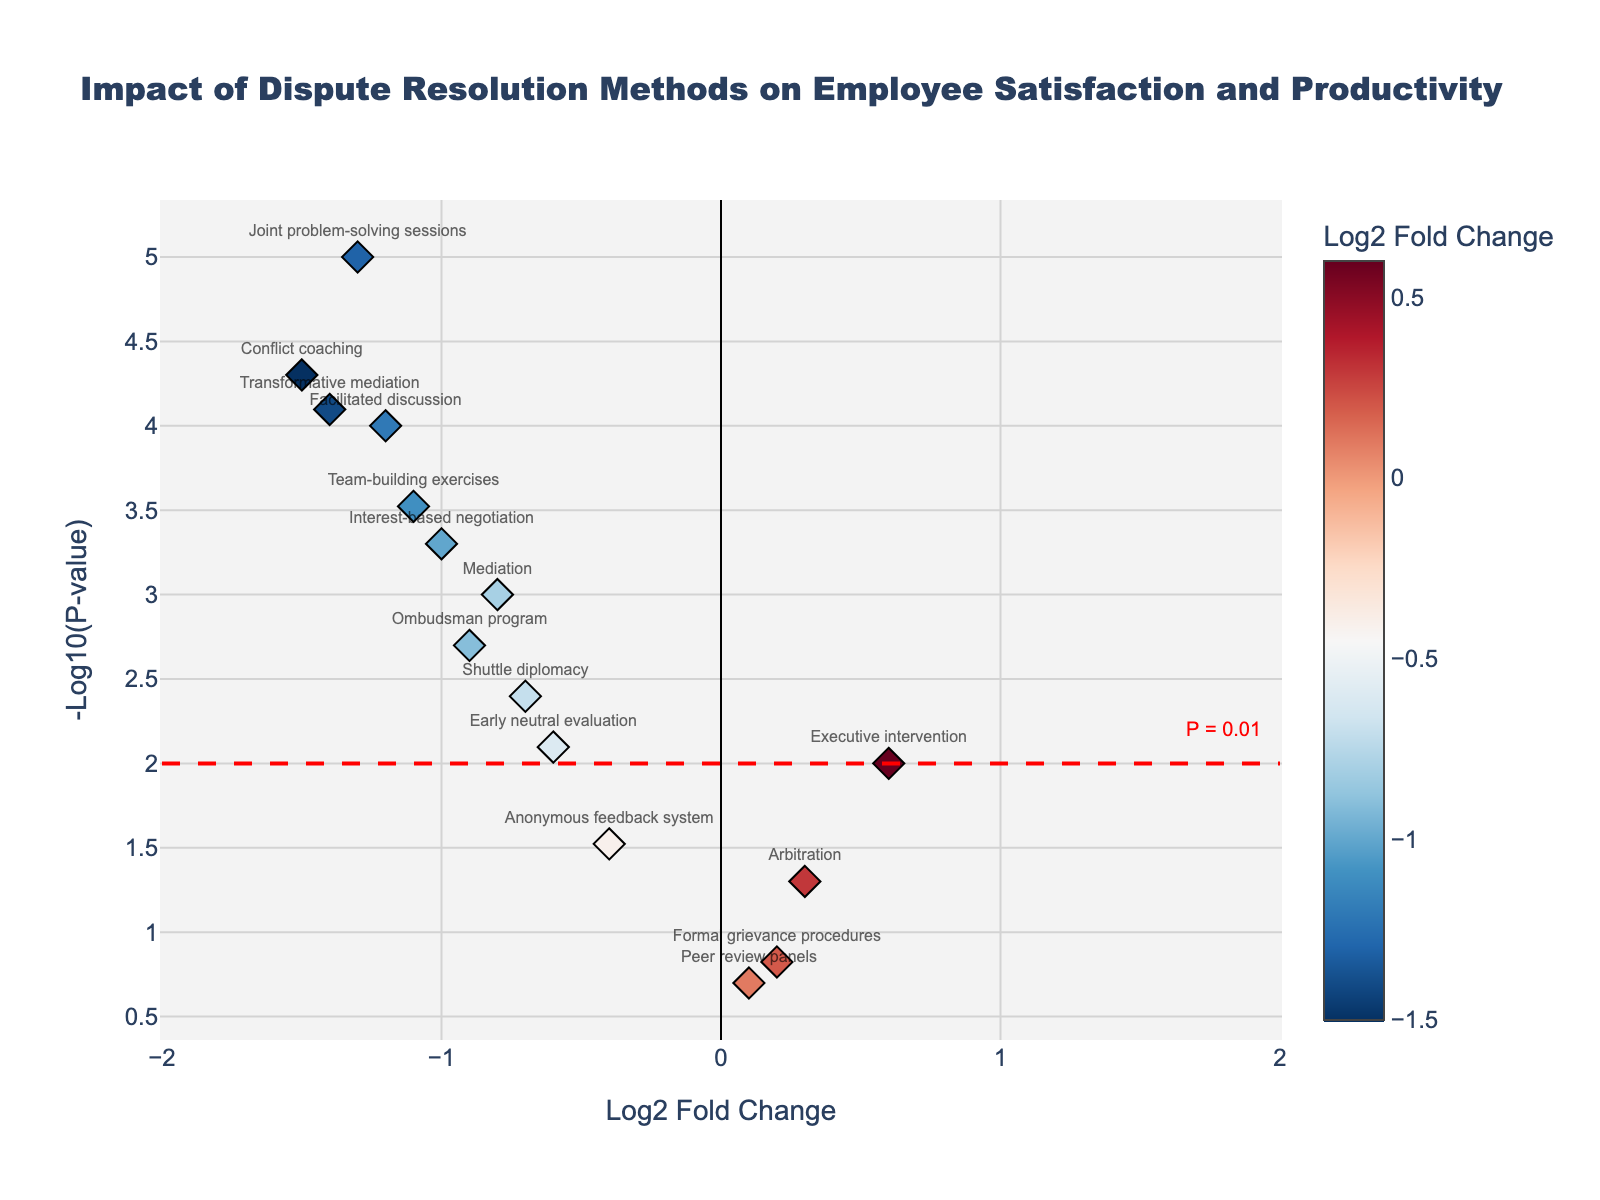What is the title of the plot? The title is displayed at the top of the plot. It reads, "Impact of Dispute Resolution Methods on Employee Satisfaction and Productivity."
Answer: Impact of Dispute Resolution Methods on Employee Satisfaction and Productivity How many data points are shown in the plot? By counting the number of markers (data points) visible in the plot, we can determine that there are 15 data points.
Answer: 15 Which dispute resolution method has the highest -log10(p-value)? The method with the highest value on the y-axis has the highest -log10(p-value). By looking at the plot, we can see "Joint problem-solving sessions" is the highest.
Answer: Joint problem-solving sessions Which dispute resolution method has the most negative log2 fold change? The most negative log2 fold change is the leftmost data point on the x-axis. This method is "Conflict coaching."
Answer: Conflict coaching Is there any method with a log2 fold change greater than 1? By observing the x-axis, we can see which methods have a log2 fold change greater than 1. None of the data points exceed 1 on the x-axis.
Answer: No Which method is closest to the threshold line for P = 0.01? The threshold line for P = 0.01 is marked at -log10(p-value) = 2. The closest data point to this line is "Early neutral evaluation."
Answer: Early neutral evaluation Which method has the smallest p-value? The method with the smallest p-value will have the highest -log10(p-value). Hence, the method at the topmost point is "Joint problem-solving sessions."
Answer: Joint problem-solving sessions How many methods have a -log10(p-value) greater than 3? By looking at the y-axis and counting points above the value of 3, we can determine the number of methods. There are three methods: "Joint problem-solving sessions," "Conflict coaching," and "Transformative mediation."
Answer: 3 Which method has a log2 fold change of approximately -0.9? By finding the data point near -0.9 on the x-axis, we identify the method. The method is "Ombudsman program."
Answer: Ombudsman program Are there more methods with positive log2 fold changes or negative log2 fold changes? Count the number of dots to the right of the y-axis (positive log2 fold change) and to the left of the y-axis (negative log2 fold change). There are more methods with negative log2 fold changes.
Answer: Negative log2 fold changes 